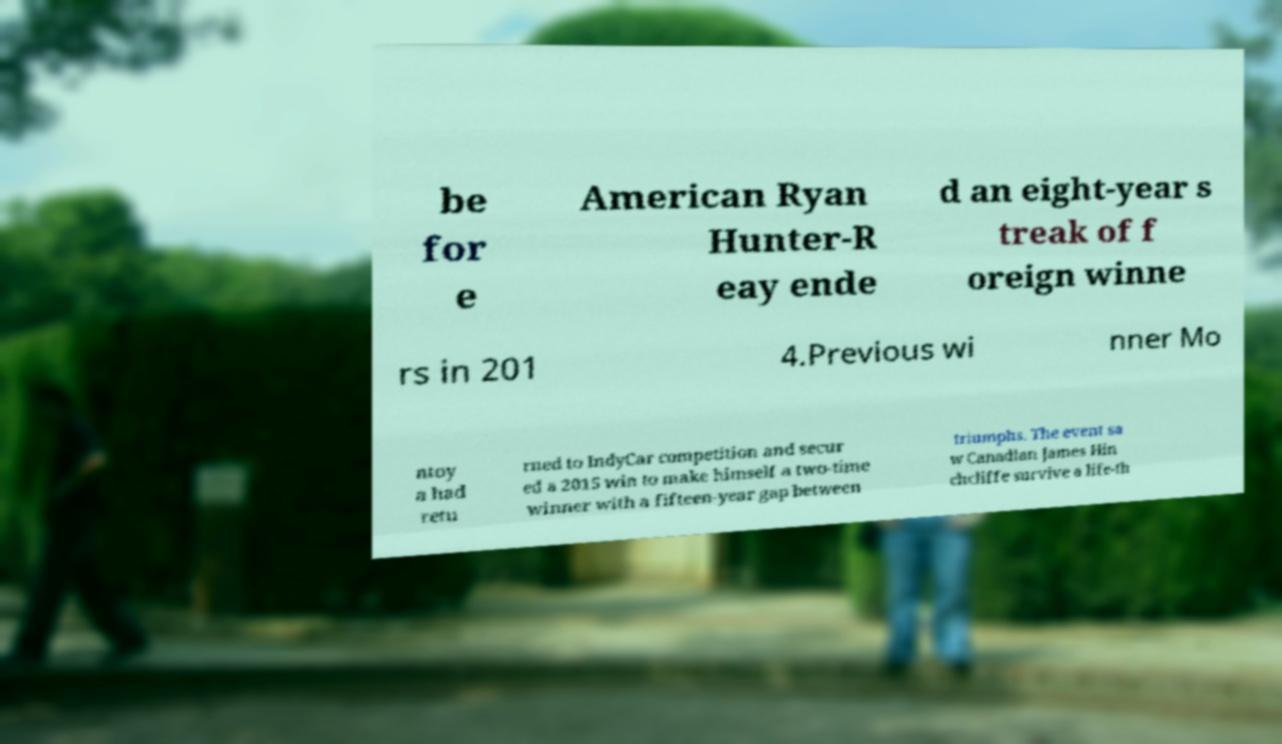Please identify and transcribe the text found in this image. be for e American Ryan Hunter-R eay ende d an eight-year s treak of f oreign winne rs in 201 4.Previous wi nner Mo ntoy a had retu rned to IndyCar competition and secur ed a 2015 win to make himself a two-time winner with a fifteen-year gap between triumphs. The event sa w Canadian James Hin chcliffe survive a life-th 